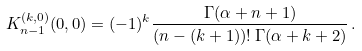<formula> <loc_0><loc_0><loc_500><loc_500>K _ { n - 1 } ^ { ( k , 0 ) } ( 0 , 0 ) = ( - 1 ) ^ { k } \frac { \Gamma ( \alpha + n + 1 ) } { ( n - ( k + 1 ) ) ! \, \Gamma ( \alpha + k + 2 ) } \, .</formula> 